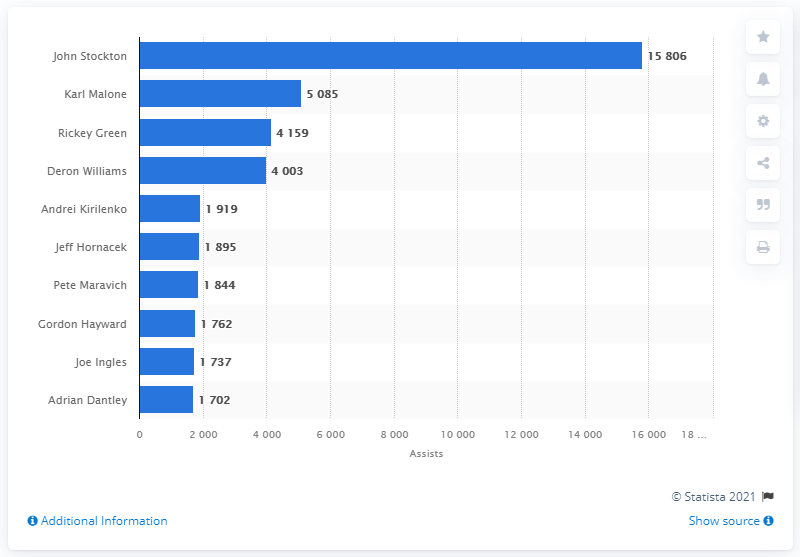Outline some significant characteristics in this image. John Stockton is the career assists leader of the Utah Jazz. 